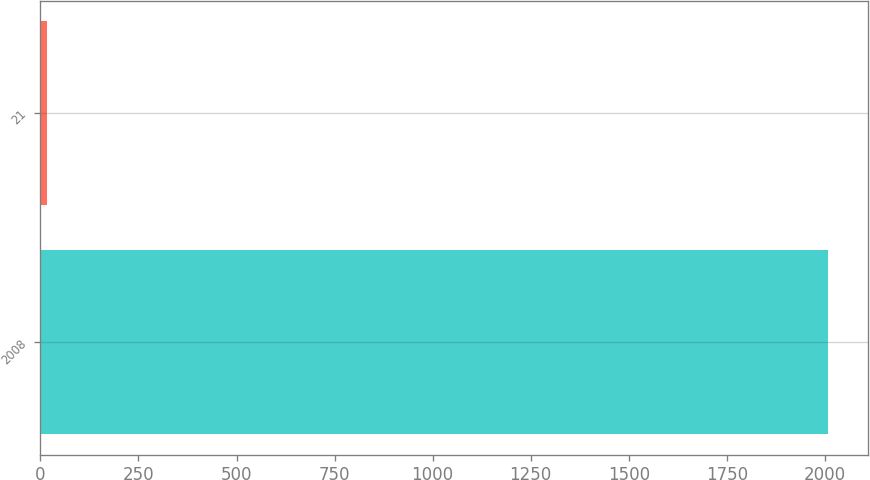<chart> <loc_0><loc_0><loc_500><loc_500><bar_chart><fcel>2008<fcel>21<nl><fcel>2009<fcel>17<nl></chart> 